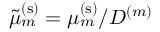<formula> <loc_0><loc_0><loc_500><loc_500>\tilde { \mu } _ { m } ^ { ( s ) } = \mu _ { m } ^ { ( s ) } / D ^ { ( m ) }</formula> 